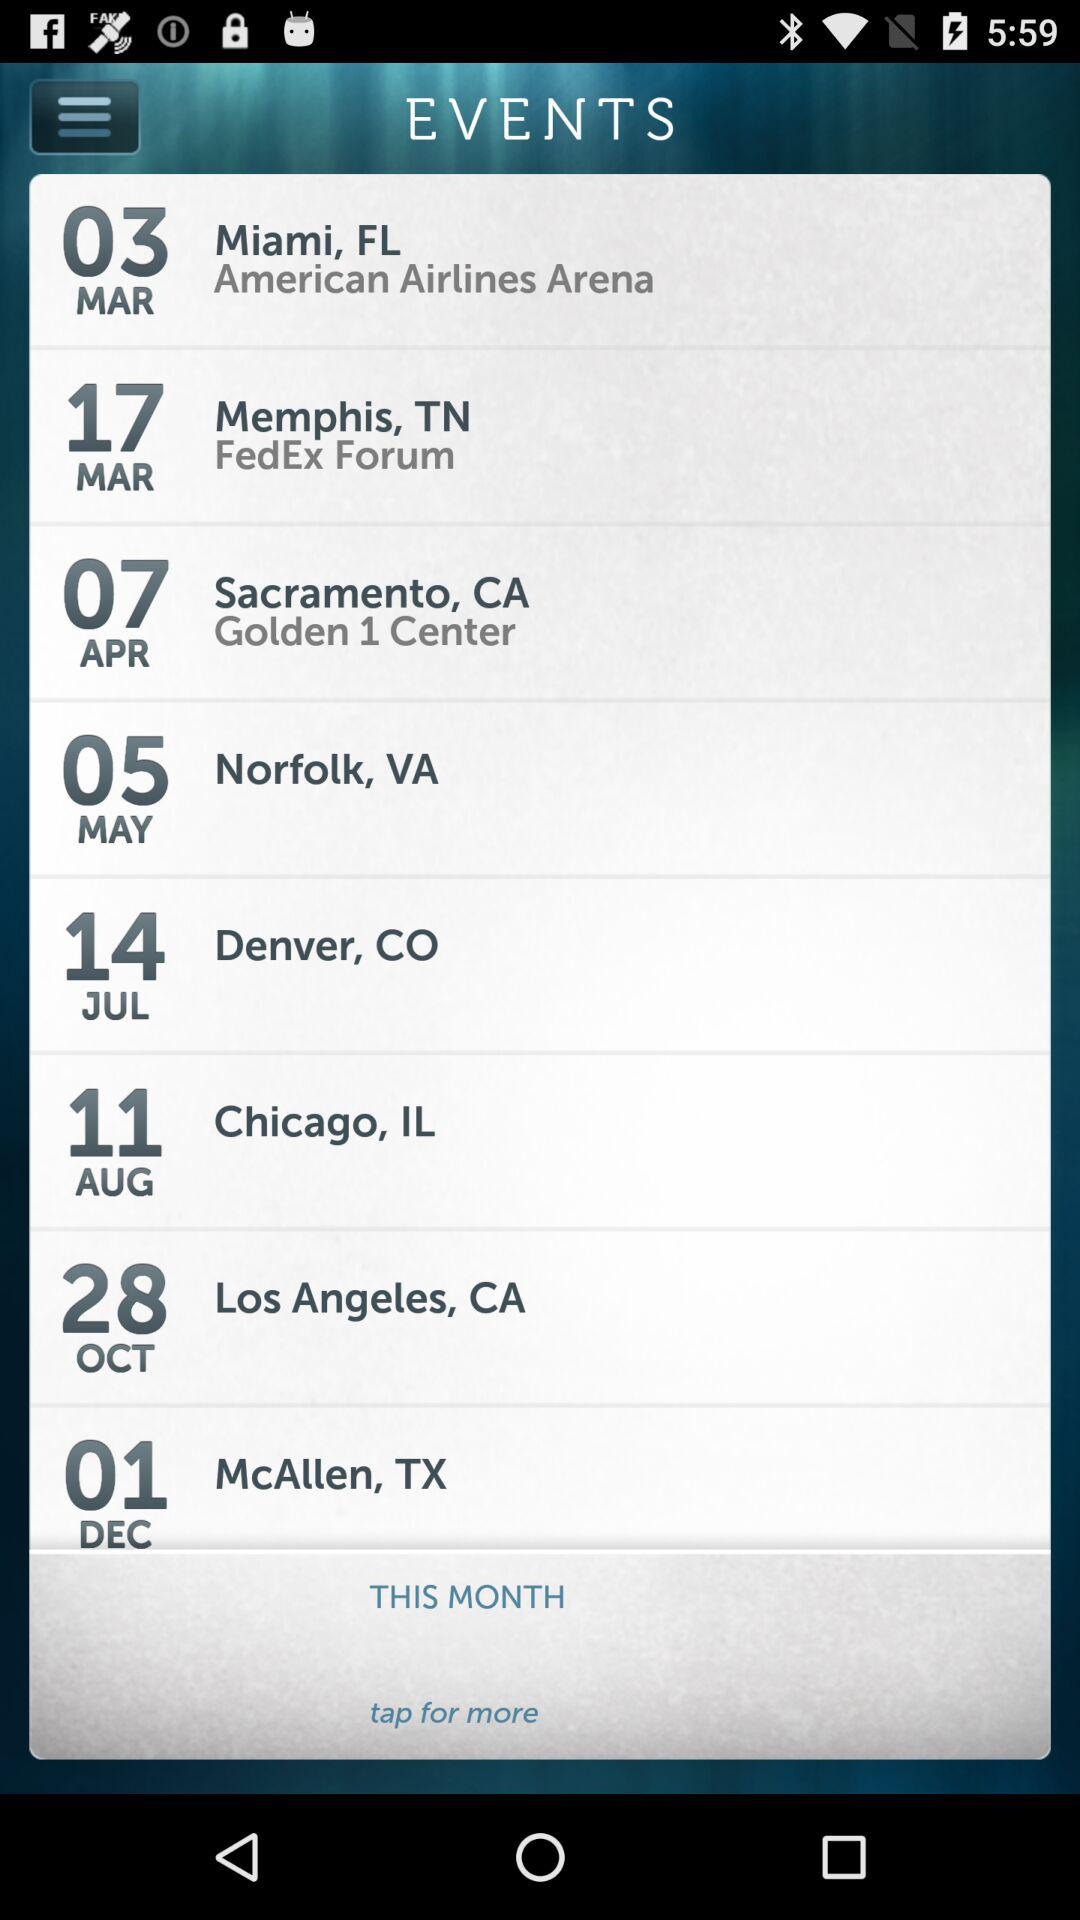How many events are in the month of March?
Answer the question using a single word or phrase. 2 